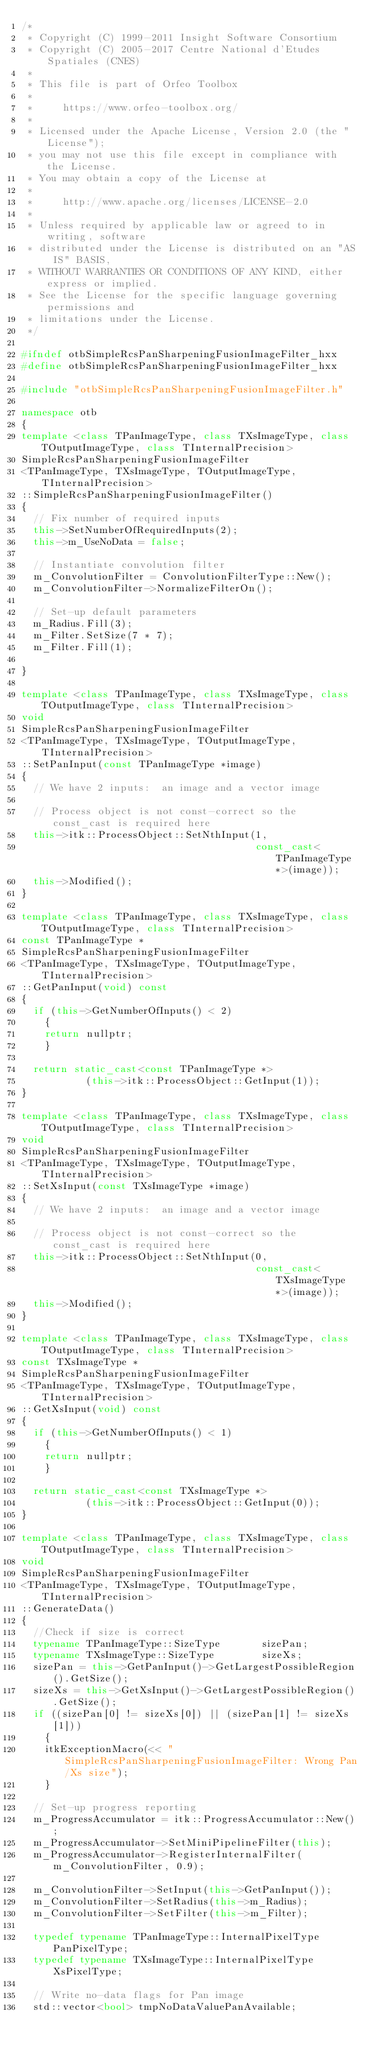Convert code to text. <code><loc_0><loc_0><loc_500><loc_500><_C++_>/*
 * Copyright (C) 1999-2011 Insight Software Consortium
 * Copyright (C) 2005-2017 Centre National d'Etudes Spatiales (CNES)
 *
 * This file is part of Orfeo Toolbox
 *
 *     https://www.orfeo-toolbox.org/
 *
 * Licensed under the Apache License, Version 2.0 (the "License");
 * you may not use this file except in compliance with the License.
 * You may obtain a copy of the License at
 *
 *     http://www.apache.org/licenses/LICENSE-2.0
 *
 * Unless required by applicable law or agreed to in writing, software
 * distributed under the License is distributed on an "AS IS" BASIS,
 * WITHOUT WARRANTIES OR CONDITIONS OF ANY KIND, either express or implied.
 * See the License for the specific language governing permissions and
 * limitations under the License.
 */

#ifndef otbSimpleRcsPanSharpeningFusionImageFilter_hxx
#define otbSimpleRcsPanSharpeningFusionImageFilter_hxx

#include "otbSimpleRcsPanSharpeningFusionImageFilter.h"

namespace otb
{
template <class TPanImageType, class TXsImageType, class TOutputImageType, class TInternalPrecision>
SimpleRcsPanSharpeningFusionImageFilter
<TPanImageType, TXsImageType, TOutputImageType, TInternalPrecision>
::SimpleRcsPanSharpeningFusionImageFilter()
{
  // Fix number of required inputs
  this->SetNumberOfRequiredInputs(2);
  this->m_UseNoData = false;

  // Instantiate convolution filter
  m_ConvolutionFilter = ConvolutionFilterType::New();
  m_ConvolutionFilter->NormalizeFilterOn();

  // Set-up default parameters
  m_Radius.Fill(3);
  m_Filter.SetSize(7 * 7);
  m_Filter.Fill(1);

}

template <class TPanImageType, class TXsImageType, class TOutputImageType, class TInternalPrecision>
void
SimpleRcsPanSharpeningFusionImageFilter
<TPanImageType, TXsImageType, TOutputImageType, TInternalPrecision>
::SetPanInput(const TPanImageType *image)
{
  // We have 2 inputs:  an image and a vector image

  // Process object is not const-correct so the const_cast is required here
  this->itk::ProcessObject::SetNthInput(1,
                                        const_cast<TPanImageType*>(image));
  this->Modified();
}

template <class TPanImageType, class TXsImageType, class TOutputImageType, class TInternalPrecision>
const TPanImageType *
SimpleRcsPanSharpeningFusionImageFilter
<TPanImageType, TXsImageType, TOutputImageType, TInternalPrecision>
::GetPanInput(void) const
{
  if (this->GetNumberOfInputs() < 2)
    {
    return nullptr;
    }

  return static_cast<const TPanImageType *>
           (this->itk::ProcessObject::GetInput(1));
}

template <class TPanImageType, class TXsImageType, class TOutputImageType, class TInternalPrecision>
void
SimpleRcsPanSharpeningFusionImageFilter
<TPanImageType, TXsImageType, TOutputImageType, TInternalPrecision>
::SetXsInput(const TXsImageType *image)
{
  // We have 2 inputs:  an image and a vector image

  // Process object is not const-correct so the const_cast is required here
  this->itk::ProcessObject::SetNthInput(0,
                                        const_cast<TXsImageType*>(image));
  this->Modified();
}

template <class TPanImageType, class TXsImageType, class TOutputImageType, class TInternalPrecision>
const TXsImageType *
SimpleRcsPanSharpeningFusionImageFilter
<TPanImageType, TXsImageType, TOutputImageType, TInternalPrecision>
::GetXsInput(void) const
{
  if (this->GetNumberOfInputs() < 1)
    {
    return nullptr;
    }

  return static_cast<const TXsImageType *>
           (this->itk::ProcessObject::GetInput(0));
}

template <class TPanImageType, class TXsImageType, class TOutputImageType, class TInternalPrecision>
void
SimpleRcsPanSharpeningFusionImageFilter
<TPanImageType, TXsImageType, TOutputImageType, TInternalPrecision>
::GenerateData()
{
  //Check if size is correct
  typename TPanImageType::SizeType       sizePan;
  typename TXsImageType::SizeType        sizeXs;
  sizePan = this->GetPanInput()->GetLargestPossibleRegion().GetSize();
  sizeXs = this->GetXsInput()->GetLargestPossibleRegion().GetSize();
  if ((sizePan[0] != sizeXs[0]) || (sizePan[1] != sizeXs[1]))
    {
    itkExceptionMacro(<< "SimpleRcsPanSharpeningFusionImageFilter: Wrong Pan/Xs size");
    }

  // Set-up progress reporting
  m_ProgressAccumulator = itk::ProgressAccumulator::New();
  m_ProgressAccumulator->SetMiniPipelineFilter(this);
  m_ProgressAccumulator->RegisterInternalFilter(m_ConvolutionFilter, 0.9);

  m_ConvolutionFilter->SetInput(this->GetPanInput());
  m_ConvolutionFilter->SetRadius(this->m_Radius);
  m_ConvolutionFilter->SetFilter(this->m_Filter);

  typedef typename TPanImageType::InternalPixelType  PanPixelType;
  typedef typename TXsImageType::InternalPixelType   XsPixelType;

  // Write no-data flags for Pan image
  std::vector<bool> tmpNoDataValuePanAvailable;</code> 